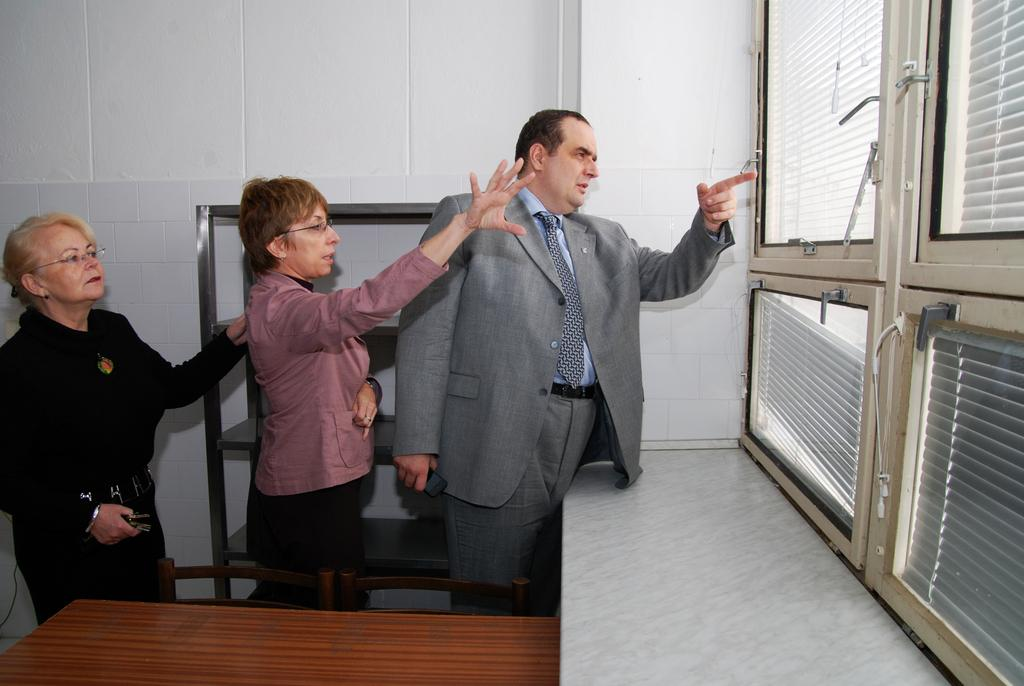How many people are present in the image? There are three people in the image. What are the people doing in the image? The people are staring outside the window, and two of them are pointing their hands toward something. What objects can be seen in front of the people? There is a table in front of the people. What is located behind the people? There is a rack behind the people. What type of breakfast is being smashed by the people in the image? There is no breakfast or smashing activity present in the image. 